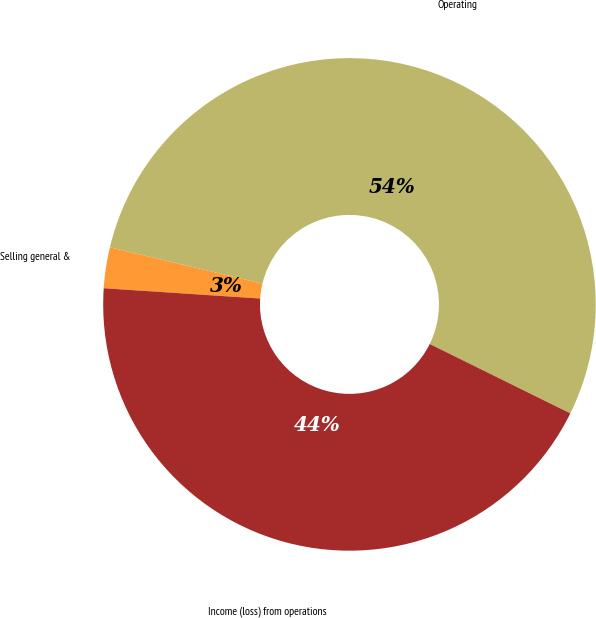<chart> <loc_0><loc_0><loc_500><loc_500><pie_chart><fcel>Operating<fcel>Selling general &<fcel>Income (loss) from operations<nl><fcel>53.57%<fcel>2.68%<fcel>43.75%<nl></chart> 